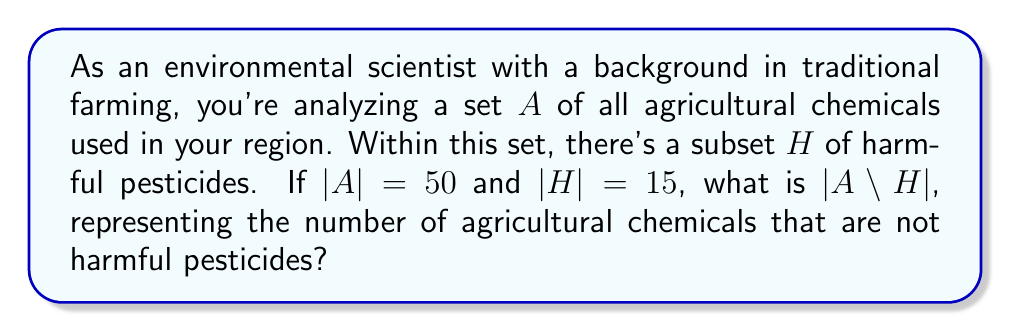Can you answer this question? To solve this problem, we need to understand the concept of set complement and how it relates to set difference. Let's break it down step-by-step:

1) The set $A$ represents all agricultural chemicals, and $H$ is a subset of $A$ containing harmful pesticides.

2) We're asked to find $|A \setminus H|$, which is the cardinality of the set difference between $A$ and $H$. This represents the number of elements in $A$ that are not in $H$.

3) In set theory, the complement of a subset $H$ with respect to the universal set $A$ is denoted as $A \setminus H$ or $H^c$.

4) The relationship between a set and its complement is given by:

   $|A| = |H| + |A \setminus H|$

5) We're given that $|A| = 50$ and $|H| = 15$. Let's substitute these values:

   $50 = 15 + |A \setminus H|$

6) Now we can solve for $|A \setminus H|$:

   $|A \setminus H| = 50 - 15 = 35$

This result tells us that there are 35 agricultural chemicals in the set $A$ that are not harmful pesticides.
Answer: $|A \setminus H| = 35$ 